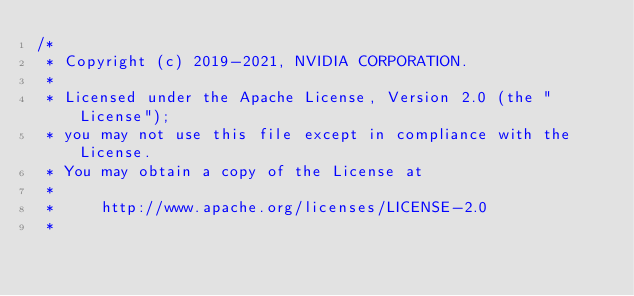<code> <loc_0><loc_0><loc_500><loc_500><_Cuda_>/*
 * Copyright (c) 2019-2021, NVIDIA CORPORATION.
 *
 * Licensed under the Apache License, Version 2.0 (the "License");
 * you may not use this file except in compliance with the License.
 * You may obtain a copy of the License at
 *
 *     http://www.apache.org/licenses/LICENSE-2.0
 *</code> 